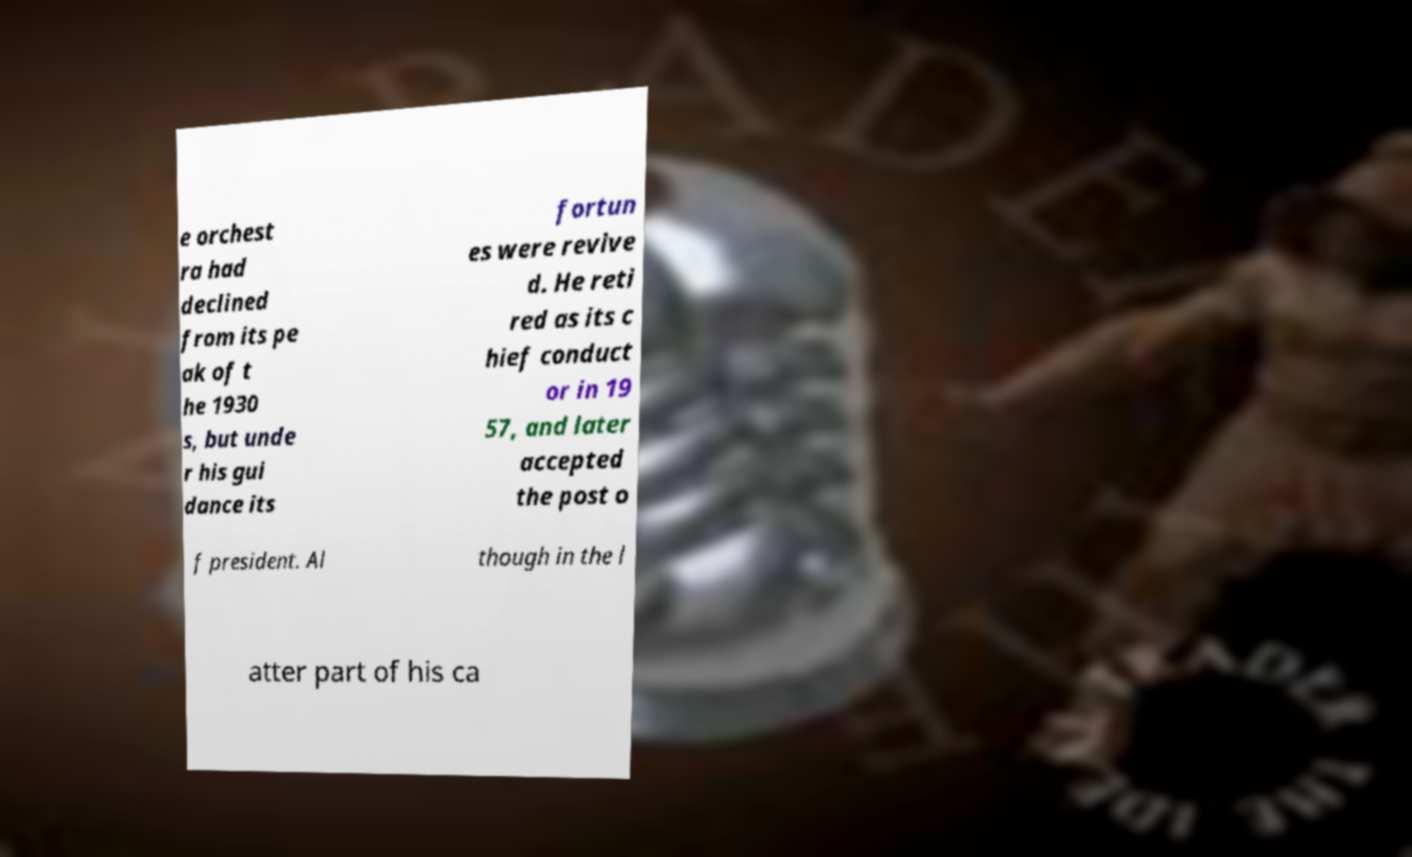Please identify and transcribe the text found in this image. e orchest ra had declined from its pe ak of t he 1930 s, but unde r his gui dance its fortun es were revive d. He reti red as its c hief conduct or in 19 57, and later accepted the post o f president. Al though in the l atter part of his ca 